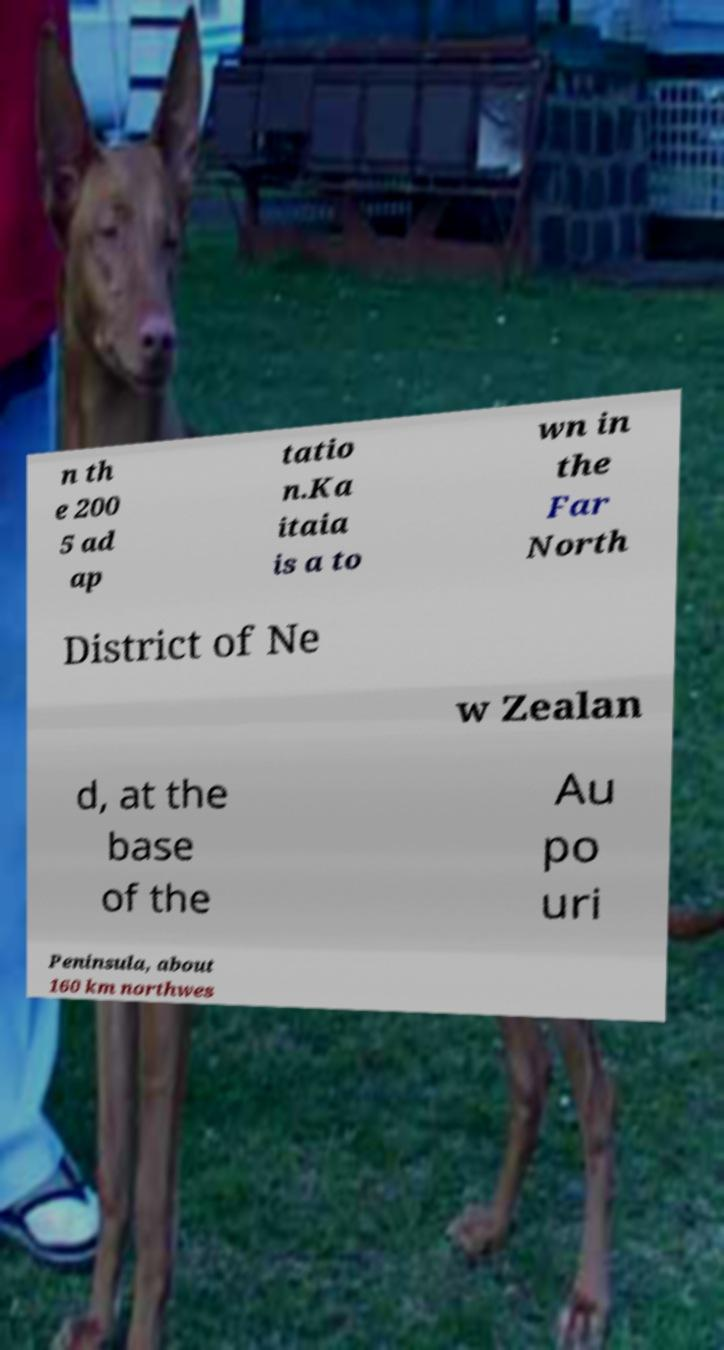Could you assist in decoding the text presented in this image and type it out clearly? n th e 200 5 ad ap tatio n.Ka itaia is a to wn in the Far North District of Ne w Zealan d, at the base of the Au po uri Peninsula, about 160 km northwes 